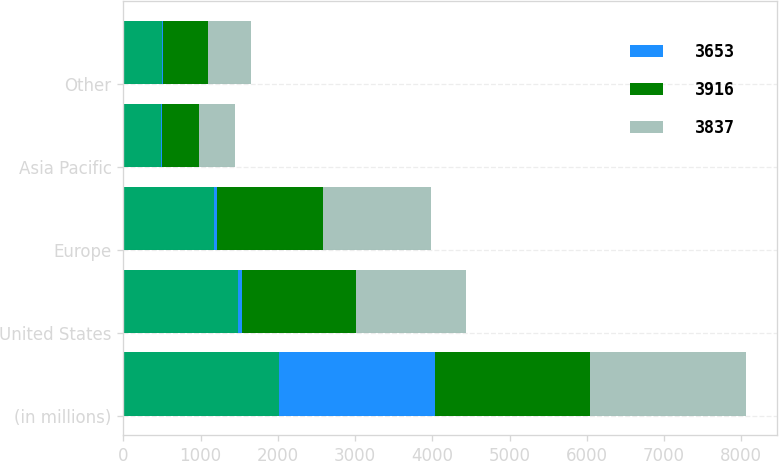<chart> <loc_0><loc_0><loc_500><loc_500><stacked_bar_chart><ecel><fcel>(in millions)<fcel>United States<fcel>Europe<fcel>Asia Pacific<fcel>Other<nl><fcel>nan<fcel>2015<fcel>1490<fcel>1179<fcel>482<fcel>502<nl><fcel>3653<fcel>2015<fcel>41<fcel>32<fcel>13<fcel>14<nl><fcel>3916<fcel>2014<fcel>1477<fcel>1379<fcel>478<fcel>582<nl><fcel>3837<fcel>2013<fcel>1434<fcel>1387<fcel>467<fcel>549<nl></chart> 